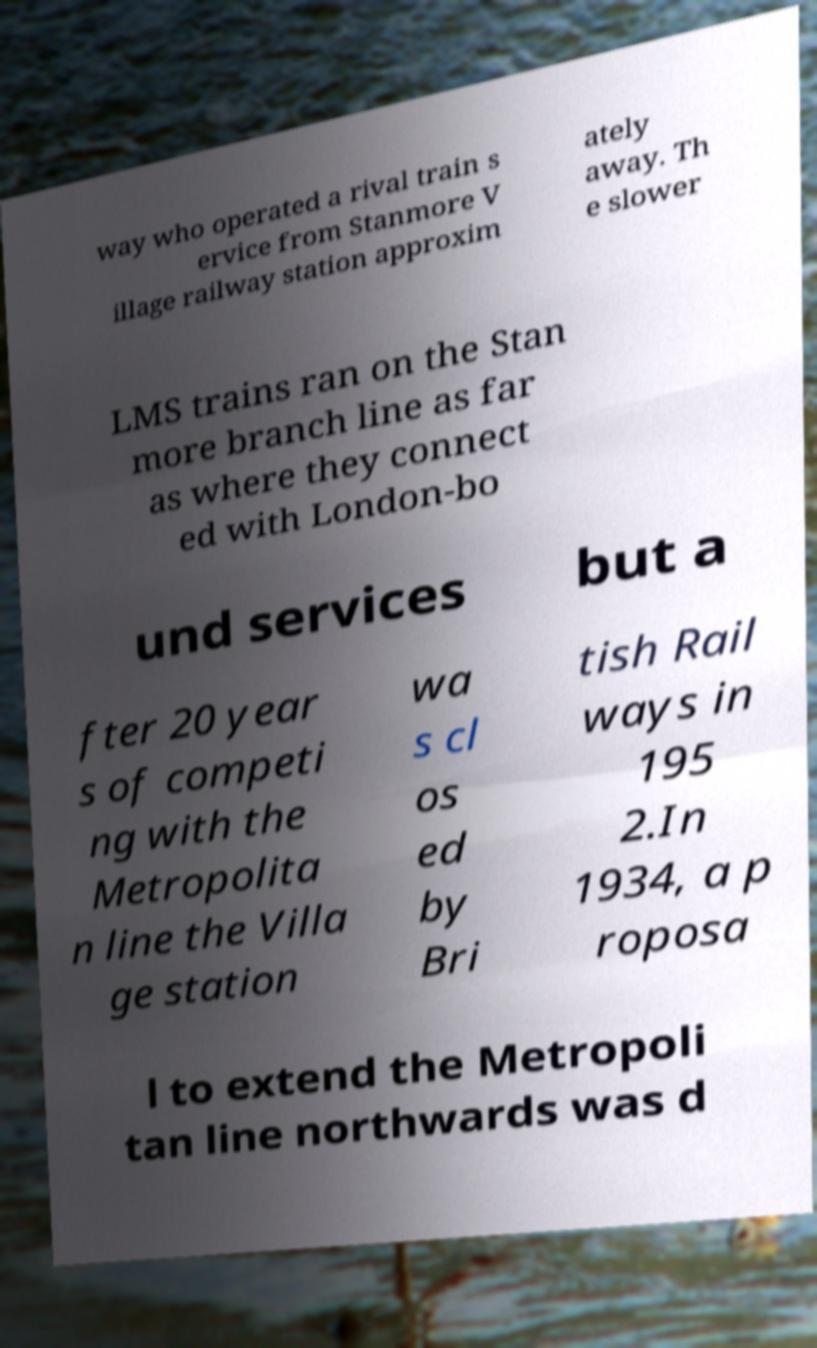Please identify and transcribe the text found in this image. way who operated a rival train s ervice from Stanmore V illage railway station approxim ately away. Th e slower LMS trains ran on the Stan more branch line as far as where they connect ed with London-bo und services but a fter 20 year s of competi ng with the Metropolita n line the Villa ge station wa s cl os ed by Bri tish Rail ways in 195 2.In 1934, a p roposa l to extend the Metropoli tan line northwards was d 